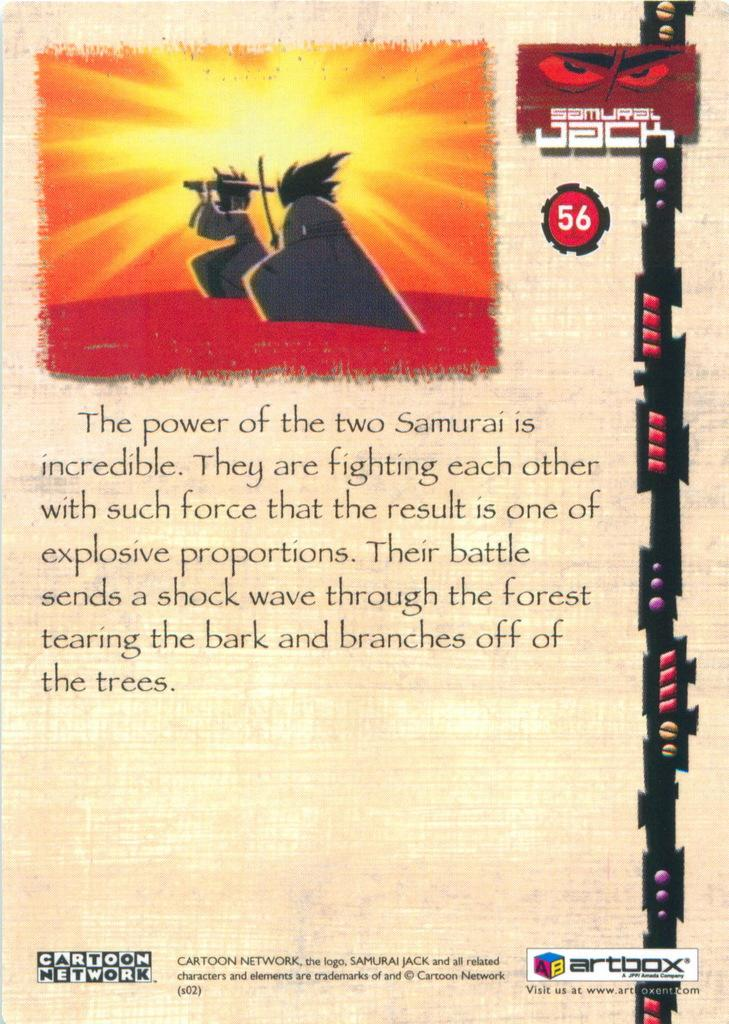<image>
Summarize the visual content of the image. An advertisement for Samurai Jack from Cartoon Network and Artbox. 